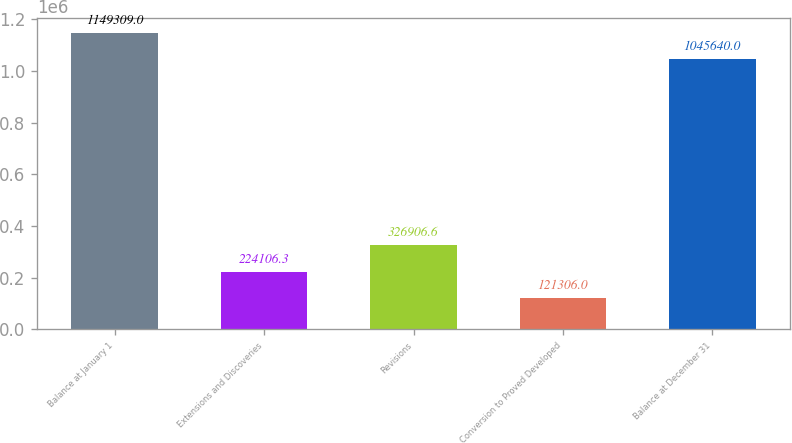Convert chart. <chart><loc_0><loc_0><loc_500><loc_500><bar_chart><fcel>Balance at January 1<fcel>Extensions and Discoveries<fcel>Revisions<fcel>Conversion to Proved Developed<fcel>Balance at December 31<nl><fcel>1.14931e+06<fcel>224106<fcel>326907<fcel>121306<fcel>1.04564e+06<nl></chart> 